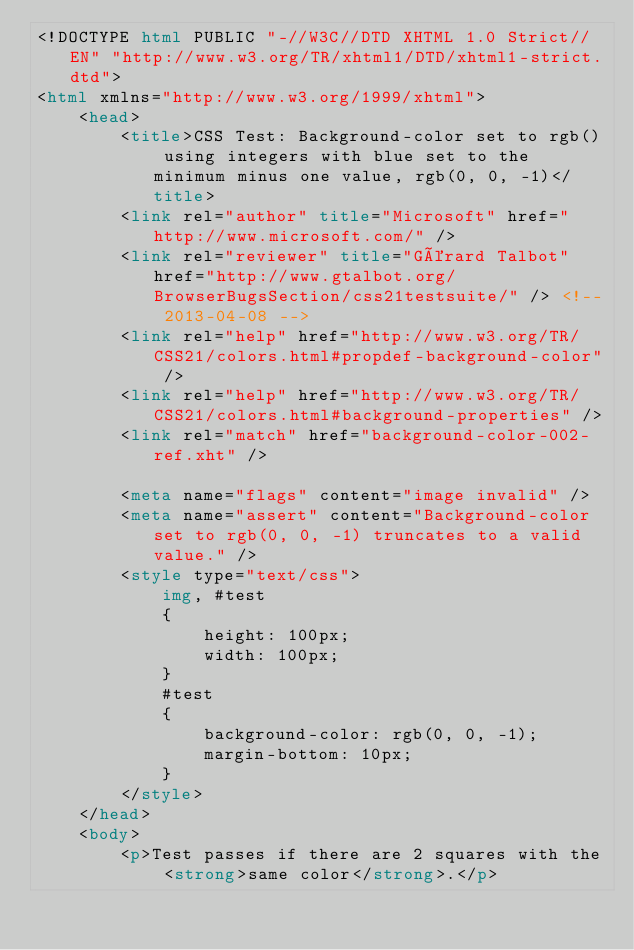<code> <loc_0><loc_0><loc_500><loc_500><_HTML_><!DOCTYPE html PUBLIC "-//W3C//DTD XHTML 1.0 Strict//EN" "http://www.w3.org/TR/xhtml1/DTD/xhtml1-strict.dtd">
<html xmlns="http://www.w3.org/1999/xhtml">
    <head>
        <title>CSS Test: Background-color set to rgb() using integers with blue set to the minimum minus one value, rgb(0, 0, -1)</title>
        <link rel="author" title="Microsoft" href="http://www.microsoft.com/" />
        <link rel="reviewer" title="Gérard Talbot" href="http://www.gtalbot.org/BrowserBugsSection/css21testsuite/" /> <!-- 2013-04-08 -->
        <link rel="help" href="http://www.w3.org/TR/CSS21/colors.html#propdef-background-color" />
        <link rel="help" href="http://www.w3.org/TR/CSS21/colors.html#background-properties" />
        <link rel="match" href="background-color-002-ref.xht" />

        <meta name="flags" content="image invalid" />
        <meta name="assert" content="Background-color set to rgb(0, 0, -1) truncates to a valid value." />
        <style type="text/css">
            img, #test
            {
                height: 100px;
                width: 100px;
            }
            #test
            {
                background-color: rgb(0, 0, -1);
                margin-bottom: 10px;
            }
        </style>
    </head>
    <body>
        <p>Test passes if there are 2 squares with the <strong>same color</strong>.</p></code> 